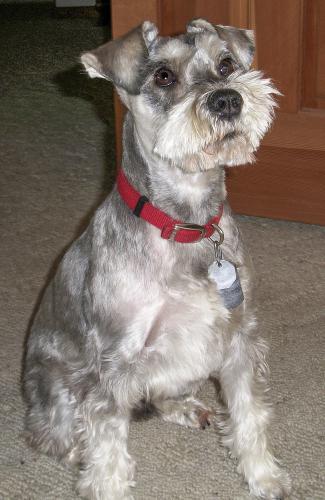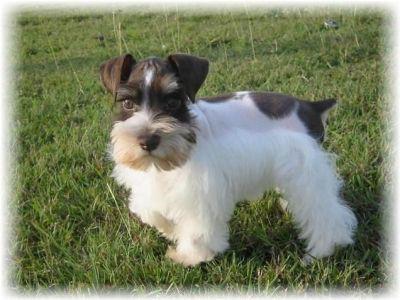The first image is the image on the left, the second image is the image on the right. For the images shown, is this caption "At least one dog is standing on grass." true? Answer yes or no. Yes. The first image is the image on the left, the second image is the image on the right. Examine the images to the left and right. Is the description "a black and white dog is standing in the grass looking at the camera" accurate? Answer yes or no. Yes. 